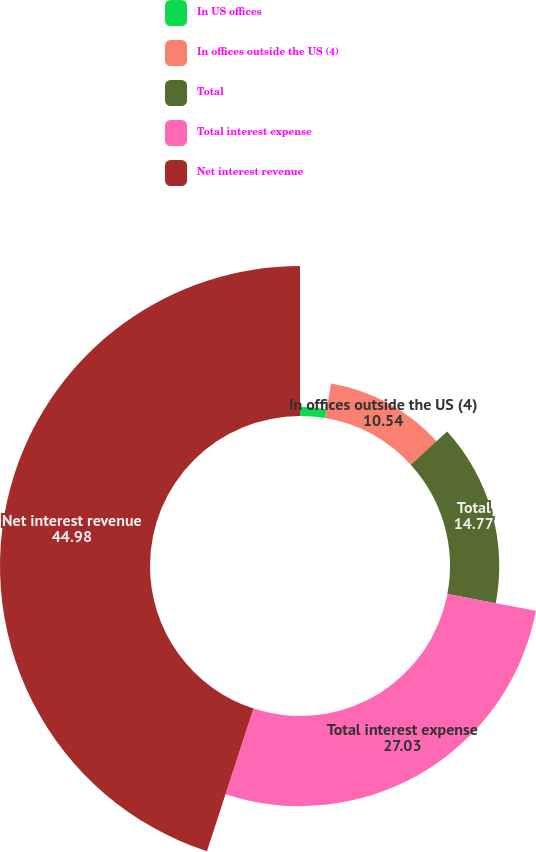Convert chart. <chart><loc_0><loc_0><loc_500><loc_500><pie_chart><fcel>In US offices<fcel>In offices outside the US (4)<fcel>Total<fcel>Total interest expense<fcel>Net interest revenue<nl><fcel>2.68%<fcel>10.54%<fcel>14.77%<fcel>27.03%<fcel>44.98%<nl></chart> 